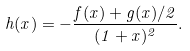Convert formula to latex. <formula><loc_0><loc_0><loc_500><loc_500>h ( x ) = - \frac { f ( x ) + g ( x ) / 2 } { ( 1 + x ) ^ { 2 } } .</formula> 